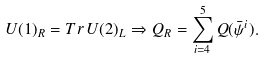<formula> <loc_0><loc_0><loc_500><loc_500>U ( 1 ) _ { R } = T r \, U ( 2 ) _ { L } \Rightarrow Q _ { R } = \sum _ { i = 4 } ^ { 5 } Q ( { \bar { \psi } } ^ { i } ) .</formula> 